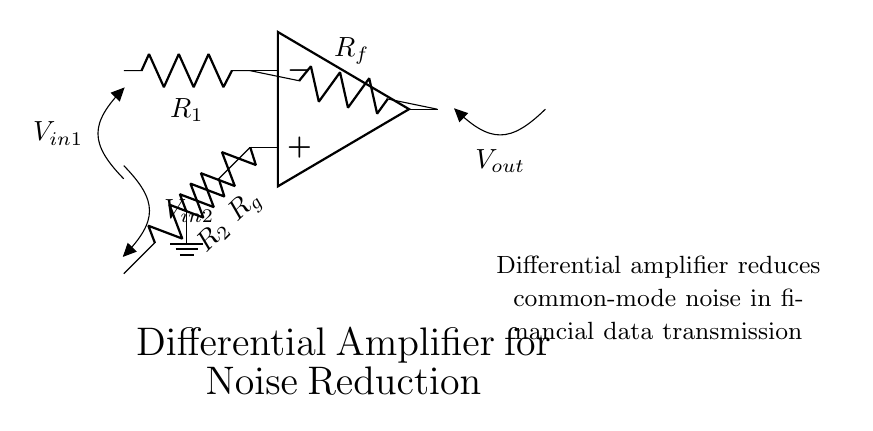What type of amplifier is shown in the diagram? The circuit diagram is labeled as a "Differential Amplifier," which specifies that it is designed to amplify the difference between two input voltages while rejecting any common-mode signals.
Answer: Differential Amplifier What components are present in the input section? The input section consists of two resistors labeled as R1 and R2, which are connected to the inverting and non-inverting terminals of the operational amplifier. This configuration allows the amplifier to process two input signals.
Answer: R1, R2 What is the purpose of Rf and Rg in the circuit? Rf serves as the feedback resistor connected to the output of the amplifier, while Rg is connected to ground. This configuration helps set the gain of the amplifier and controls its performance in terms of amplification and stability.
Answer: Feedback and gain control How does the differential amplifier reduce noise? It reduces common-mode noise by amplifying the difference between the two input voltages while rejecting any voltage that appears equally on both inputs, commonly found in noise signals. Therefore, it enables cleaner transmission of financial data.
Answer: By rejecting common-mode noise What is the expected effect on the output voltage due to changes in V_in1 and V_in2? The output voltage (V_out) will change proportionally to the difference between V_in1 and V_in2 as the amplifier amplifies this difference based on the resistor values. Thus, any variation in either input directly influences the output voltage.
Answer: Amplification of voltage difference 